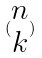Convert formula to latex. <formula><loc_0><loc_0><loc_500><loc_500>( \begin{matrix} n \\ k \end{matrix} )</formula> 